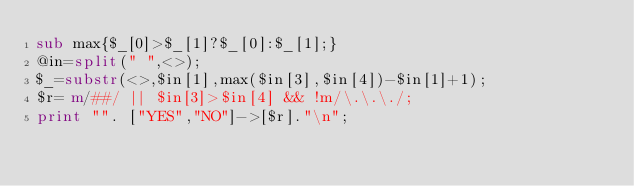<code> <loc_0><loc_0><loc_500><loc_500><_Perl_>sub max{$_[0]>$_[1]?$_[0]:$_[1];}
@in=split(" ",<>);
$_=substr(<>,$in[1],max($in[3],$in[4])-$in[1]+1);
$r= m/##/ || $in[3]>$in[4] && !m/\.\.\./;
print "". ["YES","NO"]->[$r]."\n";
</code> 